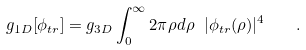Convert formula to latex. <formula><loc_0><loc_0><loc_500><loc_500>g _ { 1 D } [ \phi _ { t r } ] = g _ { 3 D } \int _ { 0 } ^ { \infty } 2 \pi \rho d \rho \ | \phi _ { t r } ( \rho ) | ^ { 4 } \quad .</formula> 